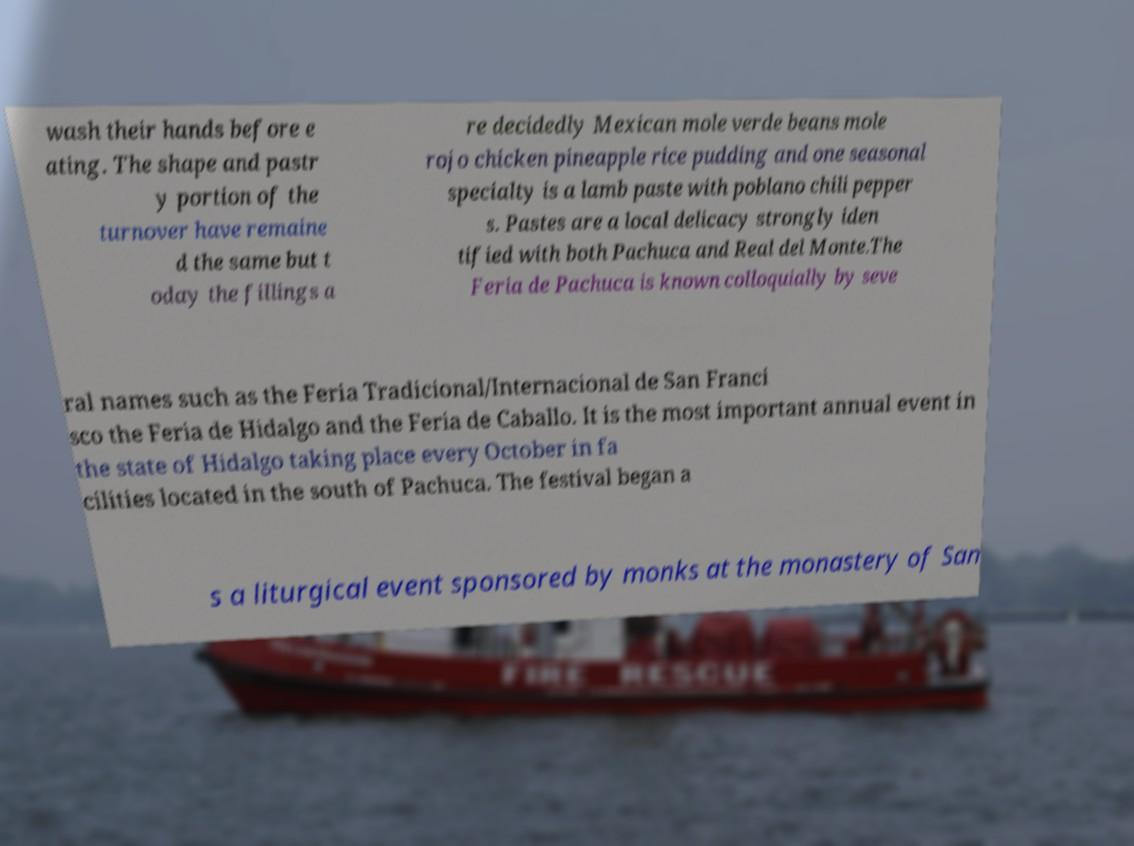There's text embedded in this image that I need extracted. Can you transcribe it verbatim? wash their hands before e ating. The shape and pastr y portion of the turnover have remaine d the same but t oday the fillings a re decidedly Mexican mole verde beans mole rojo chicken pineapple rice pudding and one seasonal specialty is a lamb paste with poblano chili pepper s. Pastes are a local delicacy strongly iden tified with both Pachuca and Real del Monte.The Feria de Pachuca is known colloquially by seve ral names such as the Feria Tradicional/Internacional de San Franci sco the Feria de Hidalgo and the Feria de Caballo. It is the most important annual event in the state of Hidalgo taking place every October in fa cilities located in the south of Pachuca. The festival began a s a liturgical event sponsored by monks at the monastery of San 